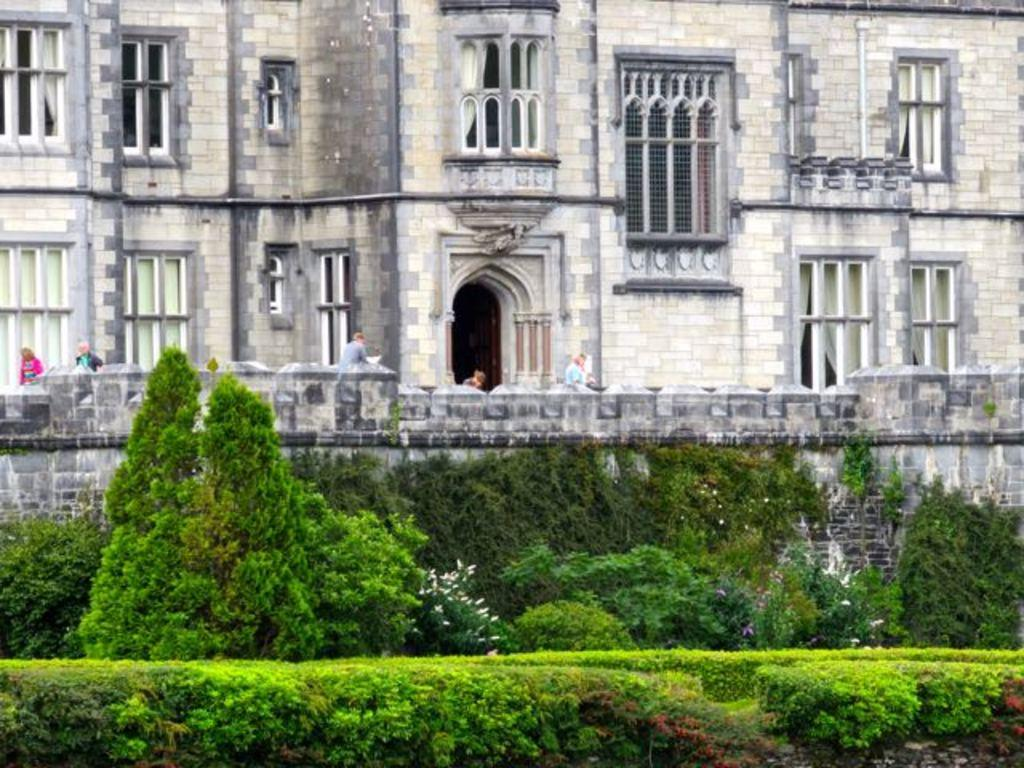What is the main subject in the center of the image? There is a building in the center of the image. Can you describe the people visible in the image? There are people visible in the image. What type of vegetation is present at the bottom of the image? Trees and bushes are present at the bottom of the image. What type of screw is holding the doll in the image? There is no screw or doll present in the image. 